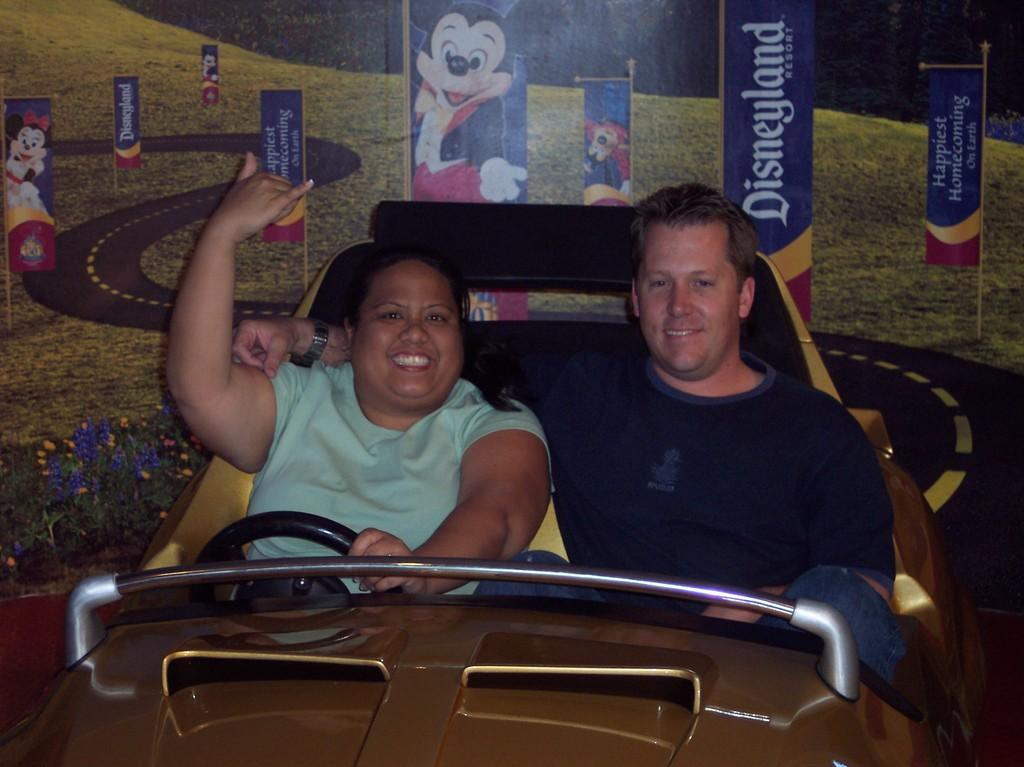What is happening in the foreground of the image? There are two people sitting in a car in the foreground of the image. What can be seen in the background of the image? There appears to be a wallpaper in the background of the image. What type of apparel is the heart wearing in the image? There is no heart or apparel present in the image. What kind of art can be seen on the wallpaper in the image? The provided facts do not mention any specific art or design on the wallpaper, so we cannot determine its appearance from the image. 